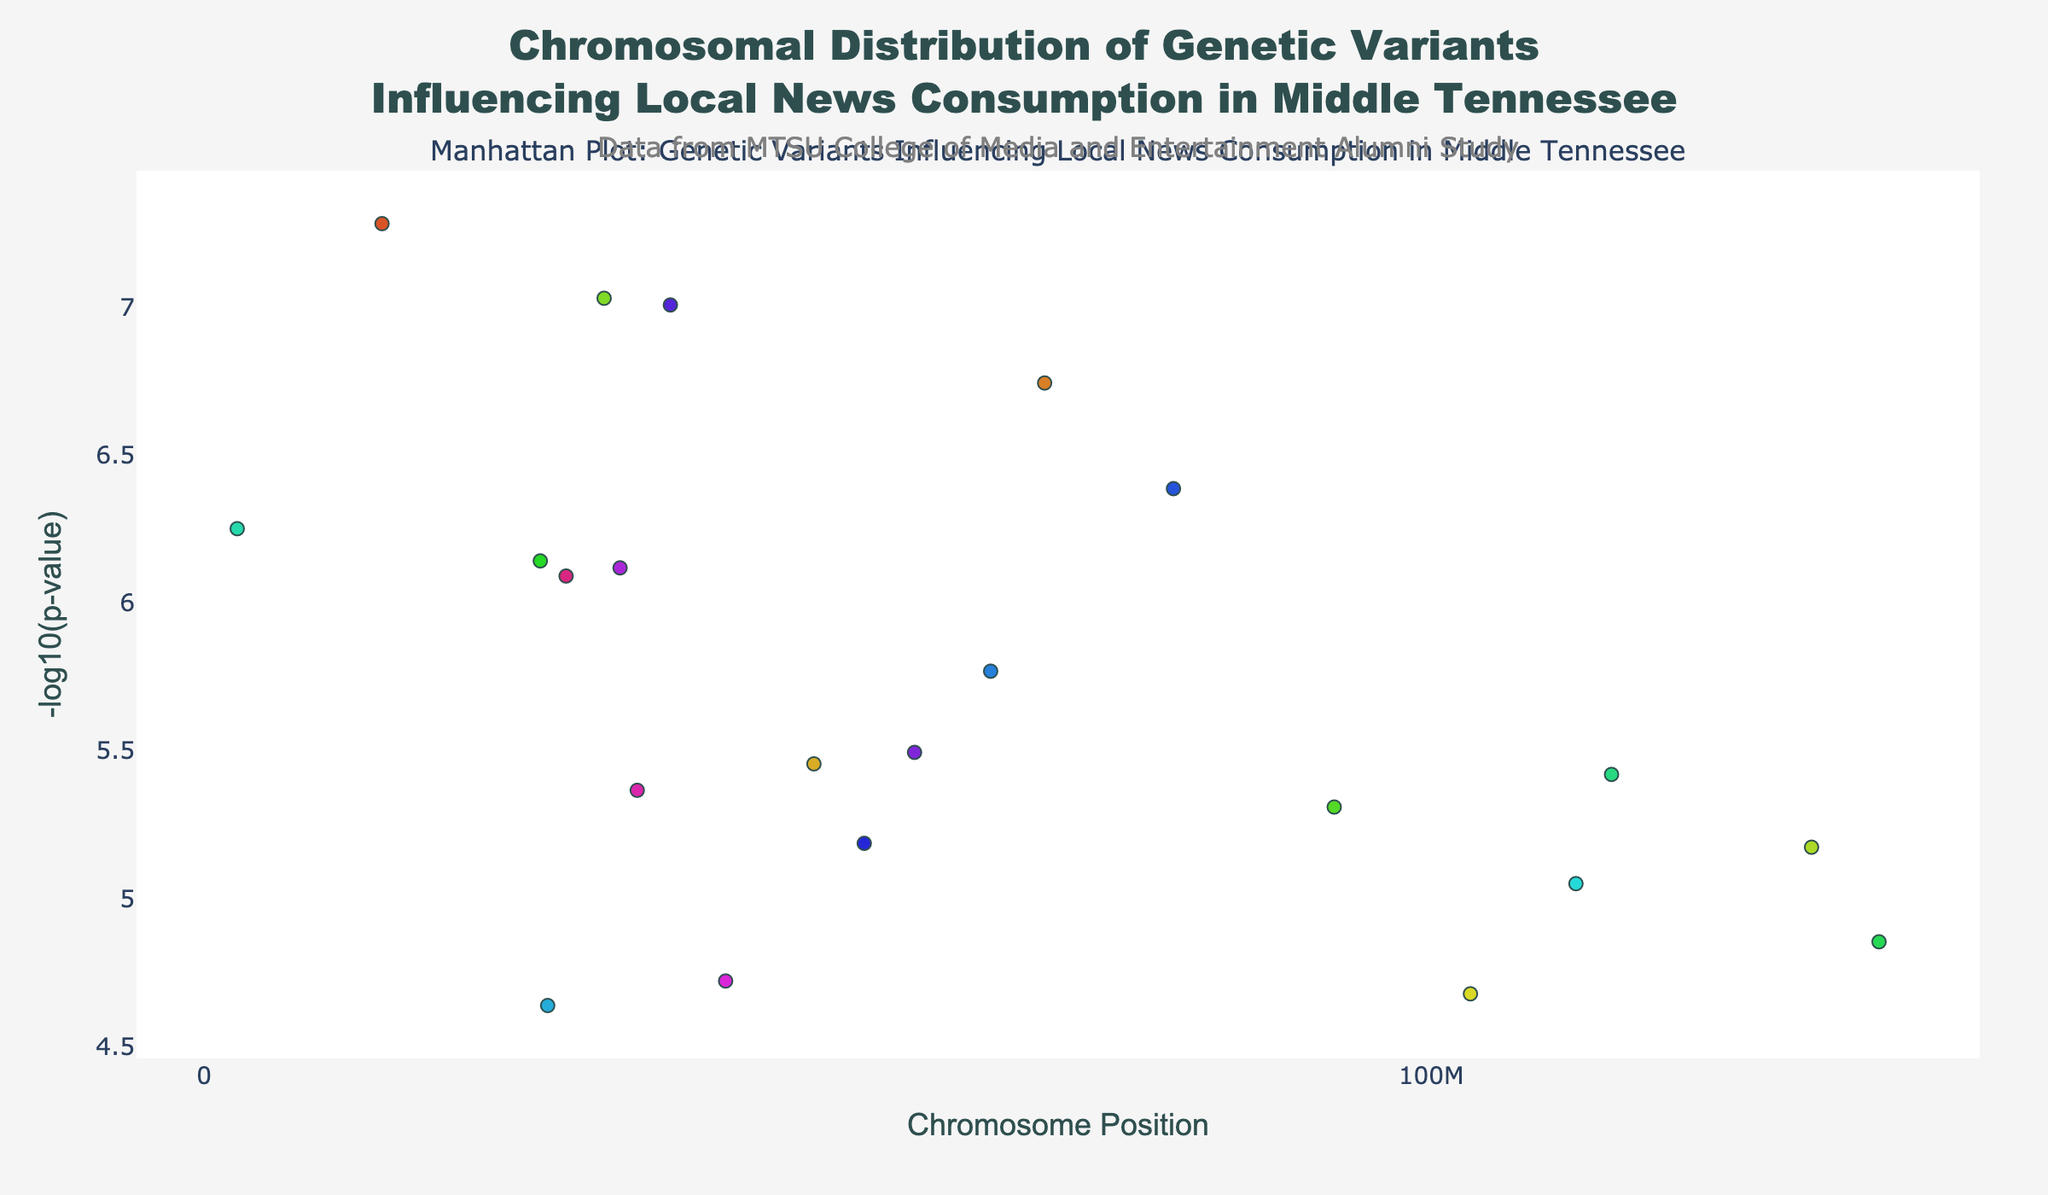What is the title of the plot? The title is displayed at the top of the plot. It reads "Chromosomal Distribution of Genetic Variants Influencing Local News Consumption in Middle Tennessee."
Answer: Chromosomal Distribution of Genetic Variants Influencing Local News Consumption in Middle Tennessee How many chromosomes are shown in the plot? Chromosomes 1 through 22 are shown, each represented by data points in distinct colors. The labels for each chromosome are indicated along the x-axis.
Answer: 22 Which chromosome has the most significant genetic variant (lowest p-value) influencing local news consumption? The significance of a genetic variant is indicated by the -log10(p-value) on the y-axis. The most significant variant will have the highest -log10(p-value). Chromosome 1 has the variant with the highest value.
Answer: Chromosome 1 What is the -log10(p-value) of the genetic variant on chromosome 6? Look at the position of the data point on chromosome 6 and read the corresponding y-value. The -log10(p-value) for the variant on chromosome 6 is slightly above 7.
Answer: Approximately 7.03 How many genetic variants have a -log10(p-value) greater than 5? Identify data points that have y-values greater than 5. By counting these points, there are 10 such variants.
Answer: 10 Which SNP has the highest -log10(p-value)? The tooltip on the plot provides the SNP information for each data point. The SNP with the highest -log10(p-value) is on chromosome 1 and is labeled rs2187668.
Answer: rs2187668 What is the approximate position of the genetic variant on chromosome 10 with the highest -log10(p-value)? Reference the data points for chromosome 10 and identify the one with the highest y-value. The position is indicated along the x-axis. For chromosome 10, the highest point is near 114,700,000.
Answer: 114,700,000 Which chromosome has a genetic variant approximately at position 40,000,000 and what is its -log10(p-value)? Look for a data point around position 40,000,000 and identify its chromosome and y-value. Chromosome 21 has a variant near this position with a -log10(p-value) of about 6.4.
Answer: Chromosome 21, -log10(p-value) approximately 6.37 Is there any chromosome without significant variants? Check if there are chromosomes with no data points shown. All chromosomes from 1 to 22 have at least one variant.
Answer: No Which chromosome has the least significant genetic variant (highest p-value) visualized in the plot? The least significant variant will have the lowest -log10(p-value) on the y-axis. The variant on chromosome 20 has the lowest value.
Answer: Chromosome 20 